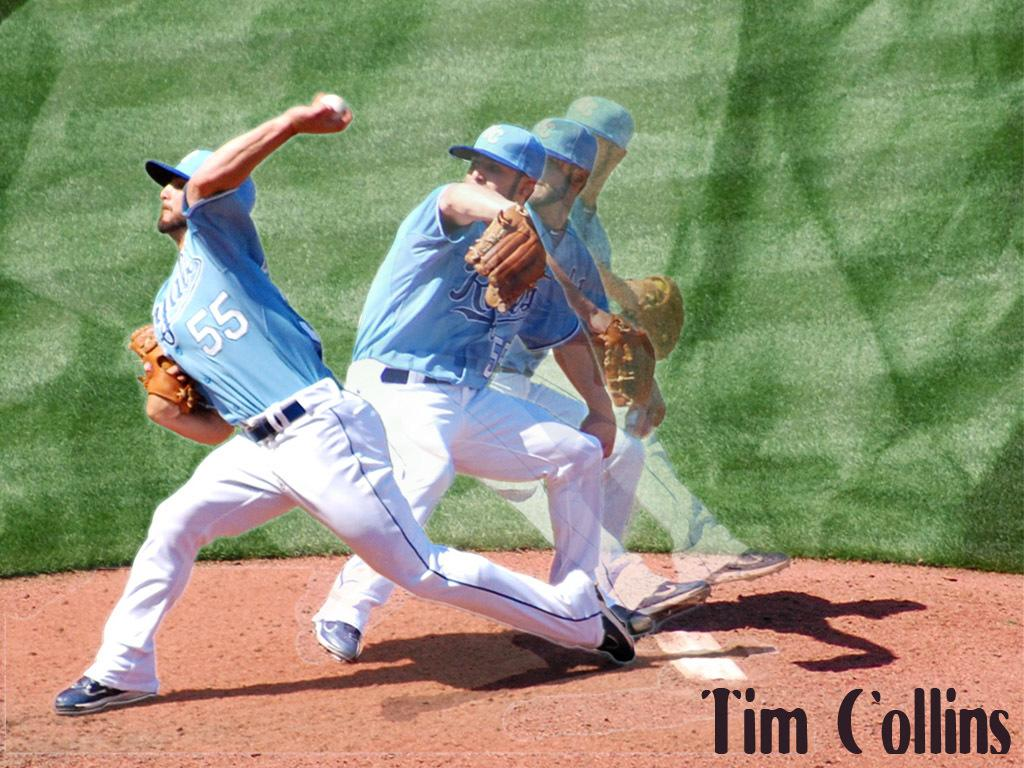<image>
Describe the image concisely. A baseball player is throwing a ball with 55 on his jersey. 